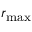Convert formula to latex. <formula><loc_0><loc_0><loc_500><loc_500>r _ { \max }</formula> 